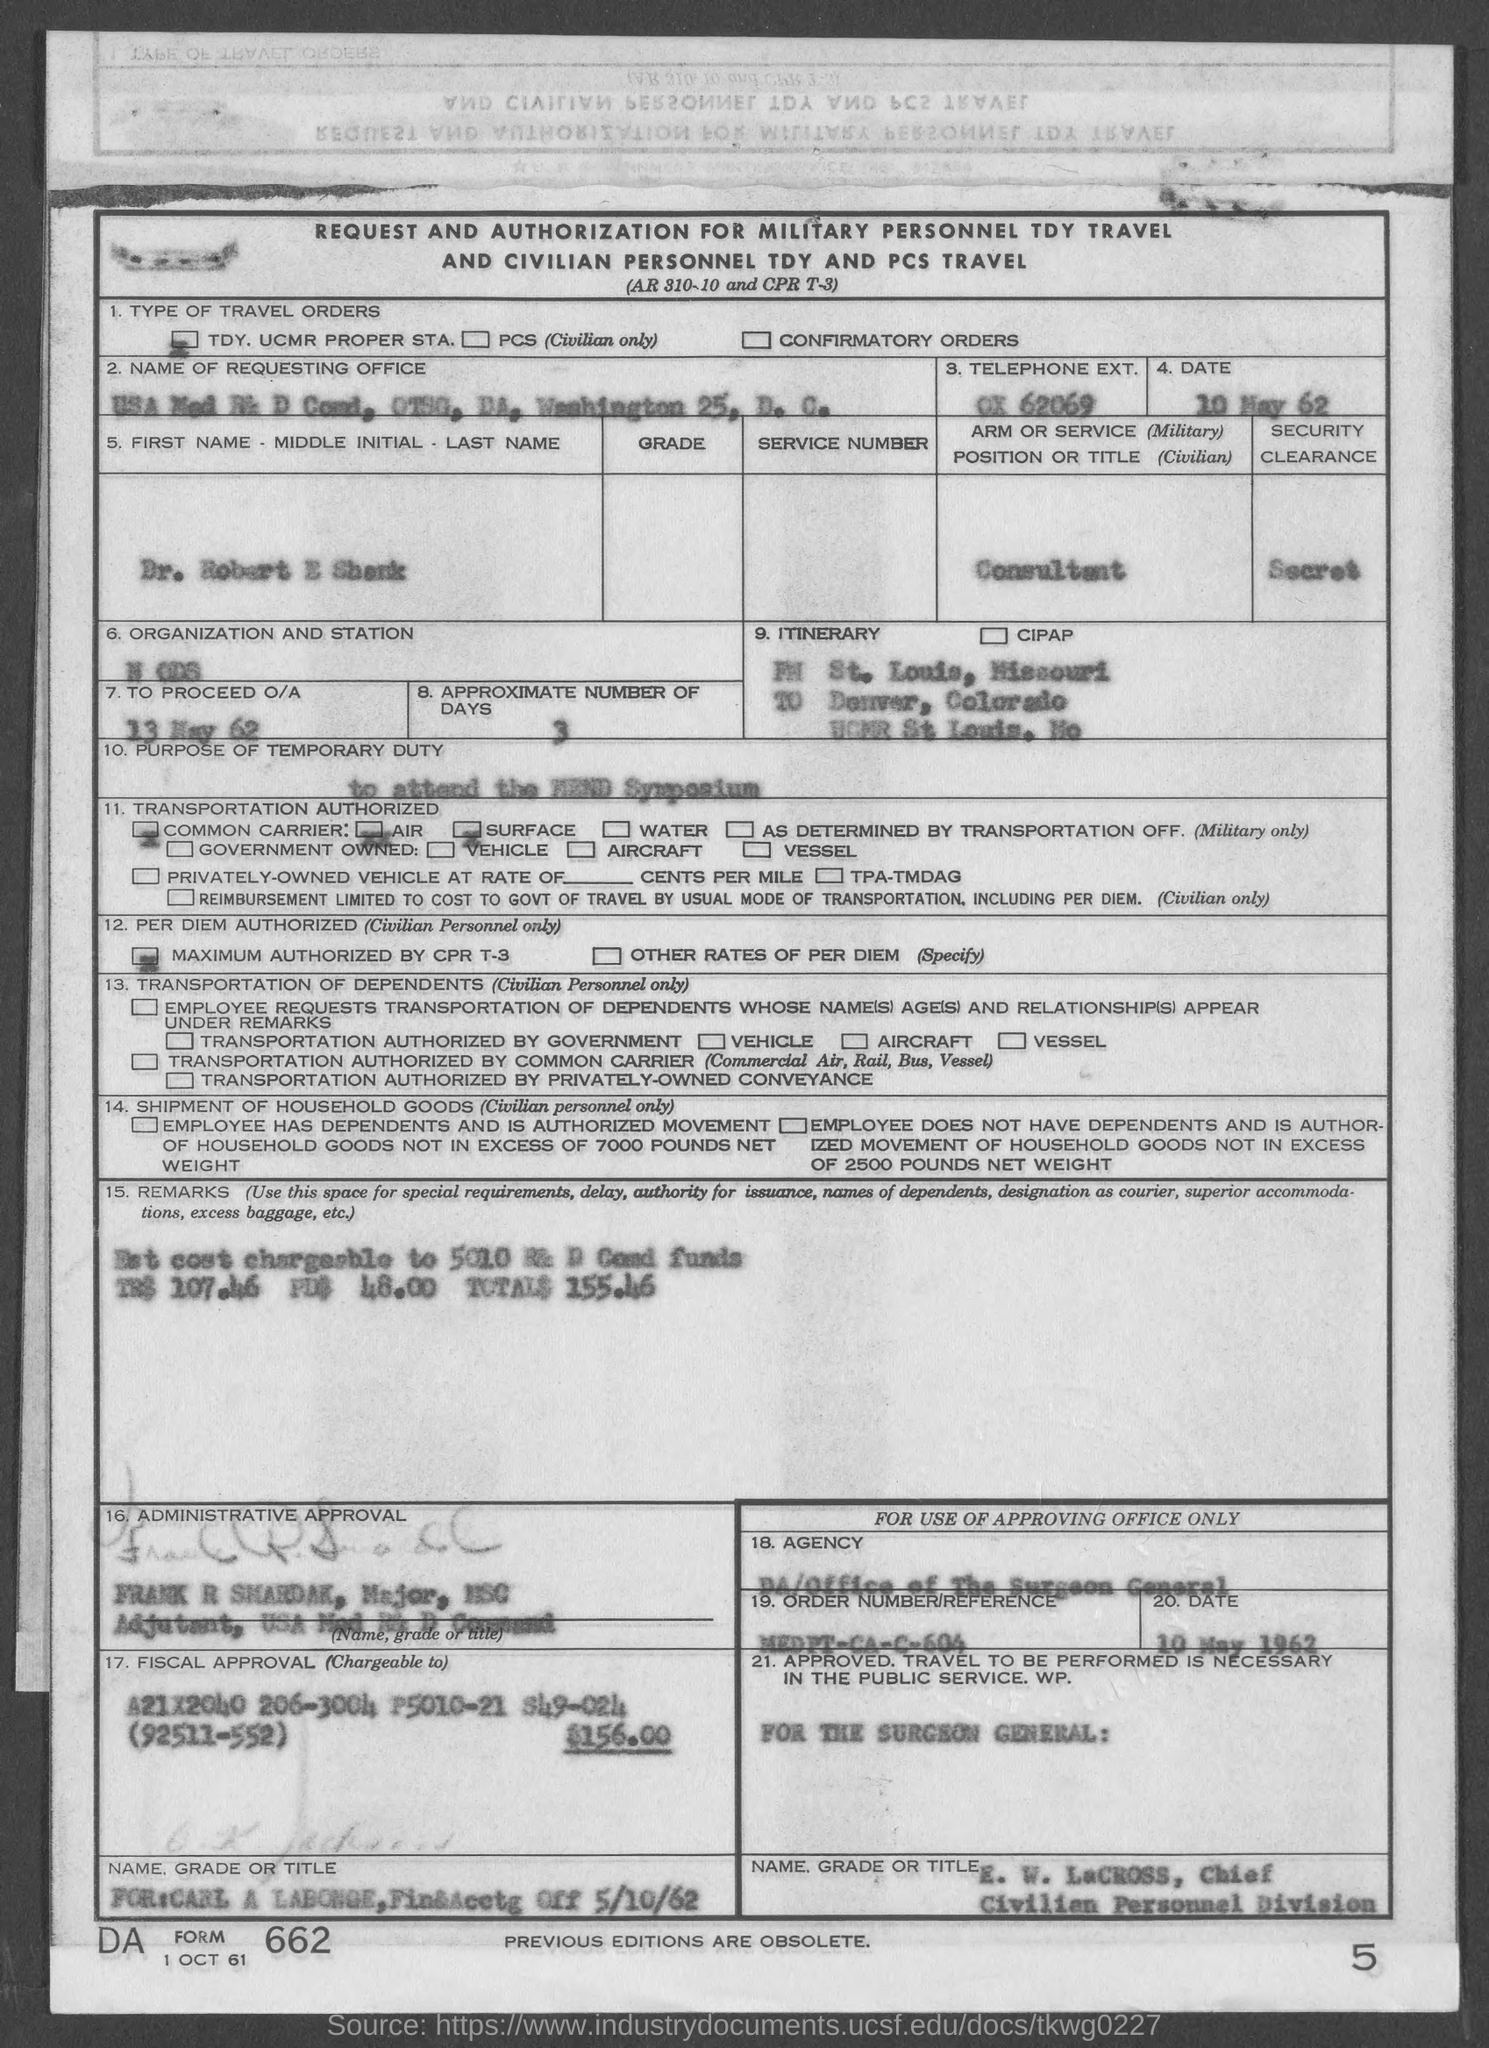Indicate a few pertinent items in this graphic. Please mention the "FORM" number indicated at the bottom left corner of the form, which is 662. The telephone number provided is 'TELEPHONE EXT.' and the prefix is ox 62069. The "APPROXIMATE NUMBER OF DAYS" mentioned in the form is 3. The "TO PROCEED O/A" mentioned in the form is a declaration indicating that the individual has read, understood, and agreed to the terms and conditions of the form as of May 13, 1962. I, [Your Name], declare that I am a consultant. 